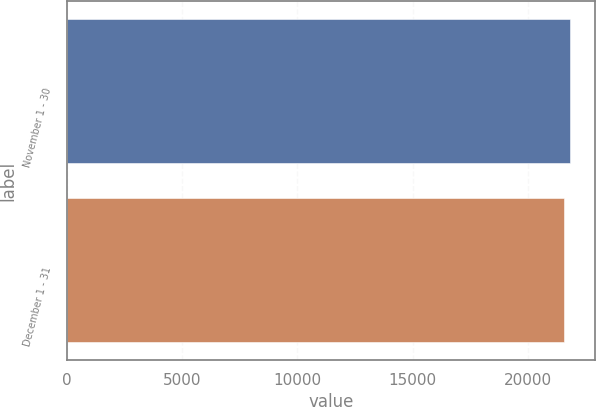<chart> <loc_0><loc_0><loc_500><loc_500><bar_chart><fcel>November 1 - 30<fcel>December 1 - 31<nl><fcel>21802<fcel>21551<nl></chart> 